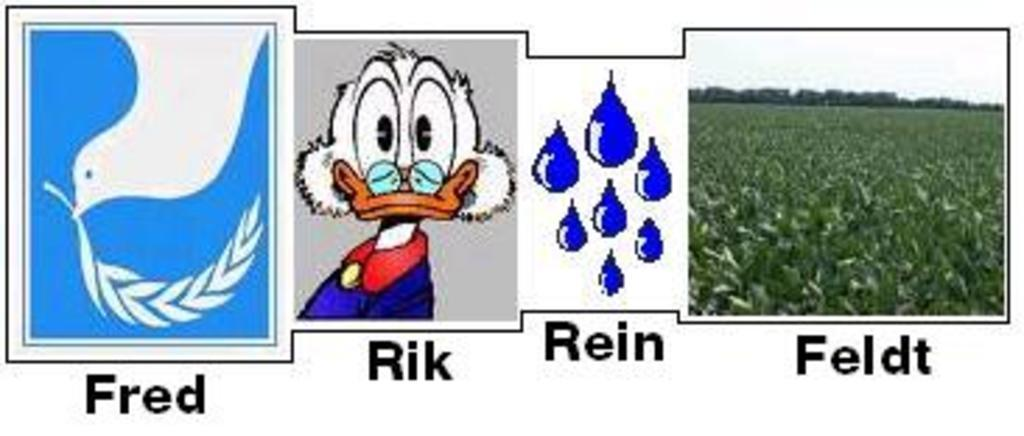What type of animated pictures can be seen in the image? There are animated pictures of a bird, Donald, and raindrops in the image. What is located on the right side of the image? There is a farm visible on the right side of the image. What can be seen in the sky in the image? The sky is visible in the image. Can you tell if it's day or night in the image? The image appears to be taken during the day. What type of oranges are being served for the meal in the image? There are no oranges or meals present in the image; it features animated pictures of a bird, Donald, and raindrops, along with a farm and the sky. 